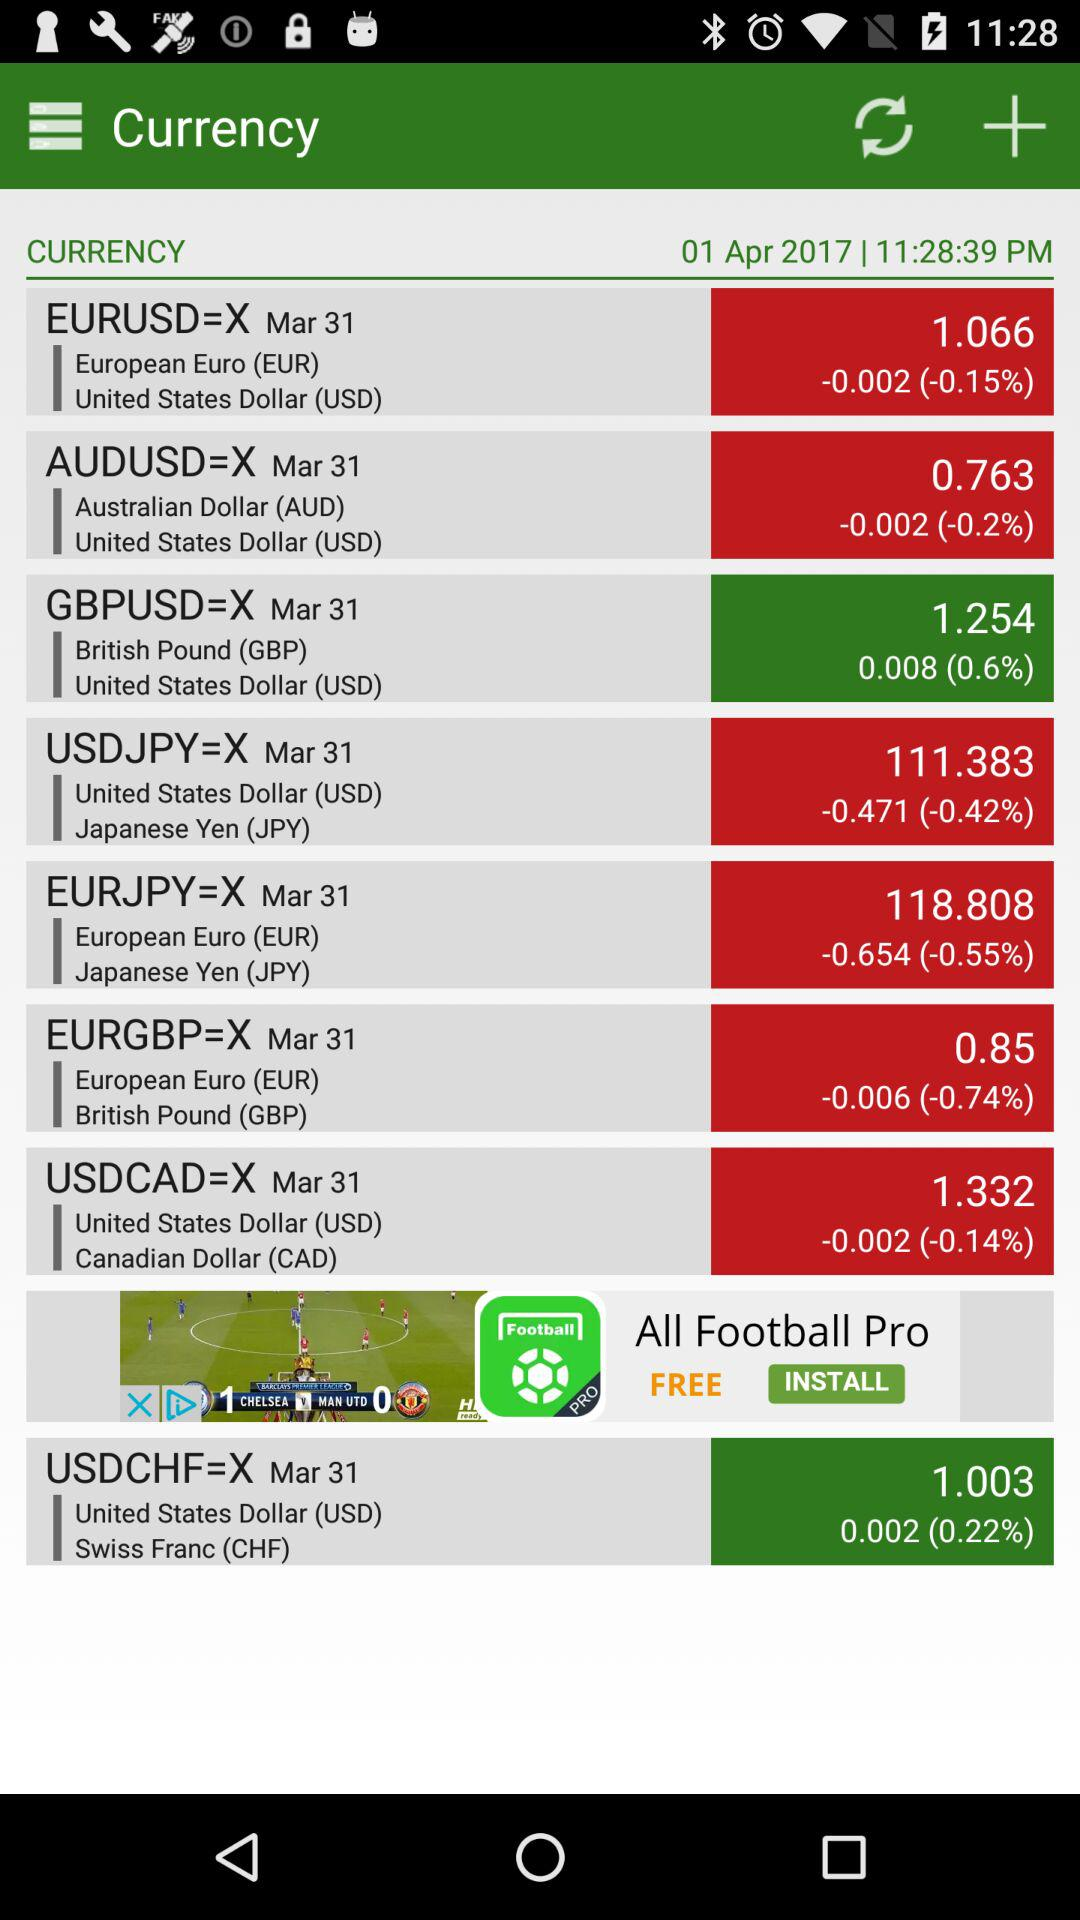Which countries' exchange rates are in green?
When the provided information is insufficient, respond with <no answer>. <no answer> 